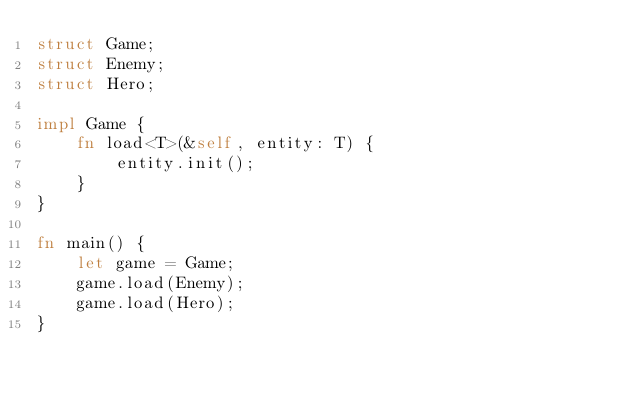<code> <loc_0><loc_0><loc_500><loc_500><_Rust_>struct Game;
struct Enemy;
struct Hero;

impl Game {
    fn load<T>(&self, entity: T) {
        entity.init();
    }
}

fn main() {
    let game = Game;
    game.load(Enemy);
    game.load(Hero);
}
</code> 